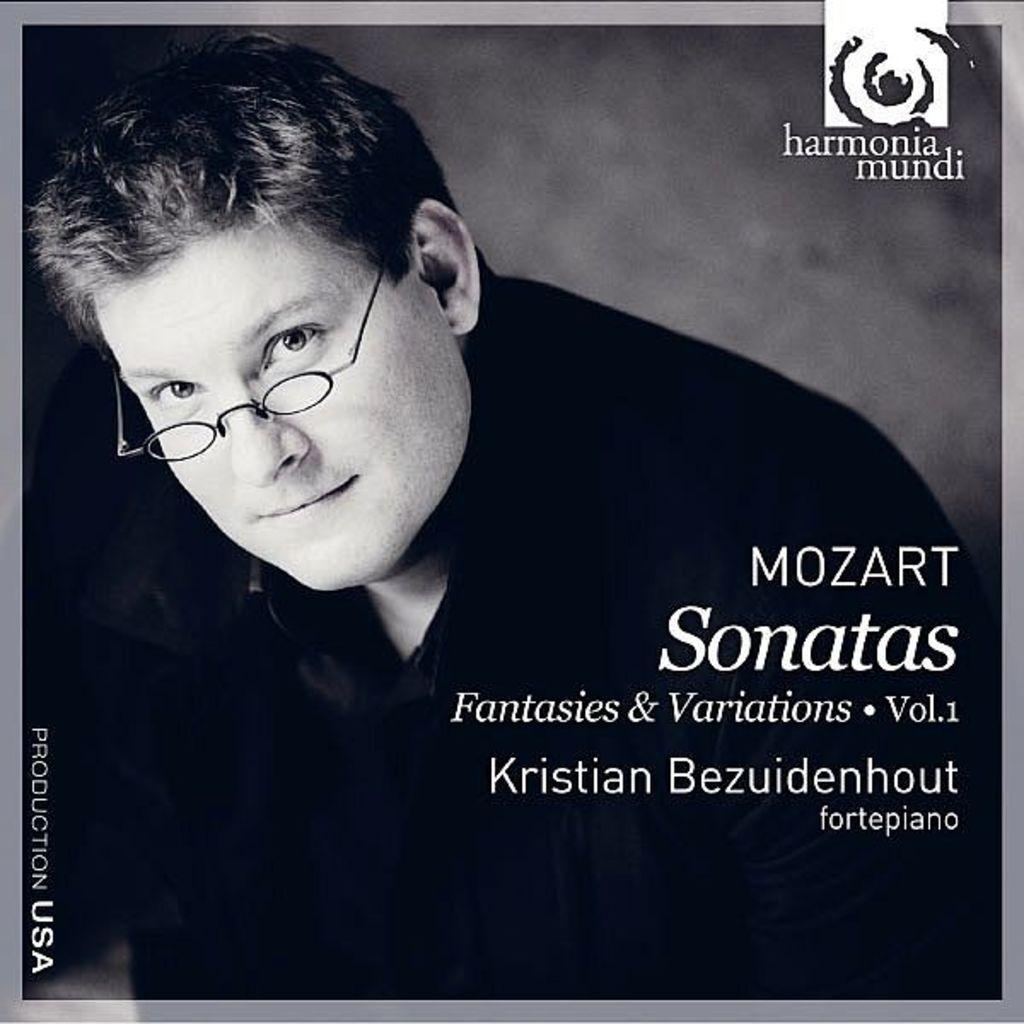What feature surrounds the main content of the image? The image has borders. Who is the main subject in the foreground of the image? There is a person in the foreground of the image. What accessory is the person wearing? The person is wearing spectacles. What additional information can be found on the image? There is text visible on the image. Can you tell me how many pigs are visible in the image? There are no pigs present in the image. What stage of development is the person in the image experiencing? The image does not provide information about the person's developmental stage. 